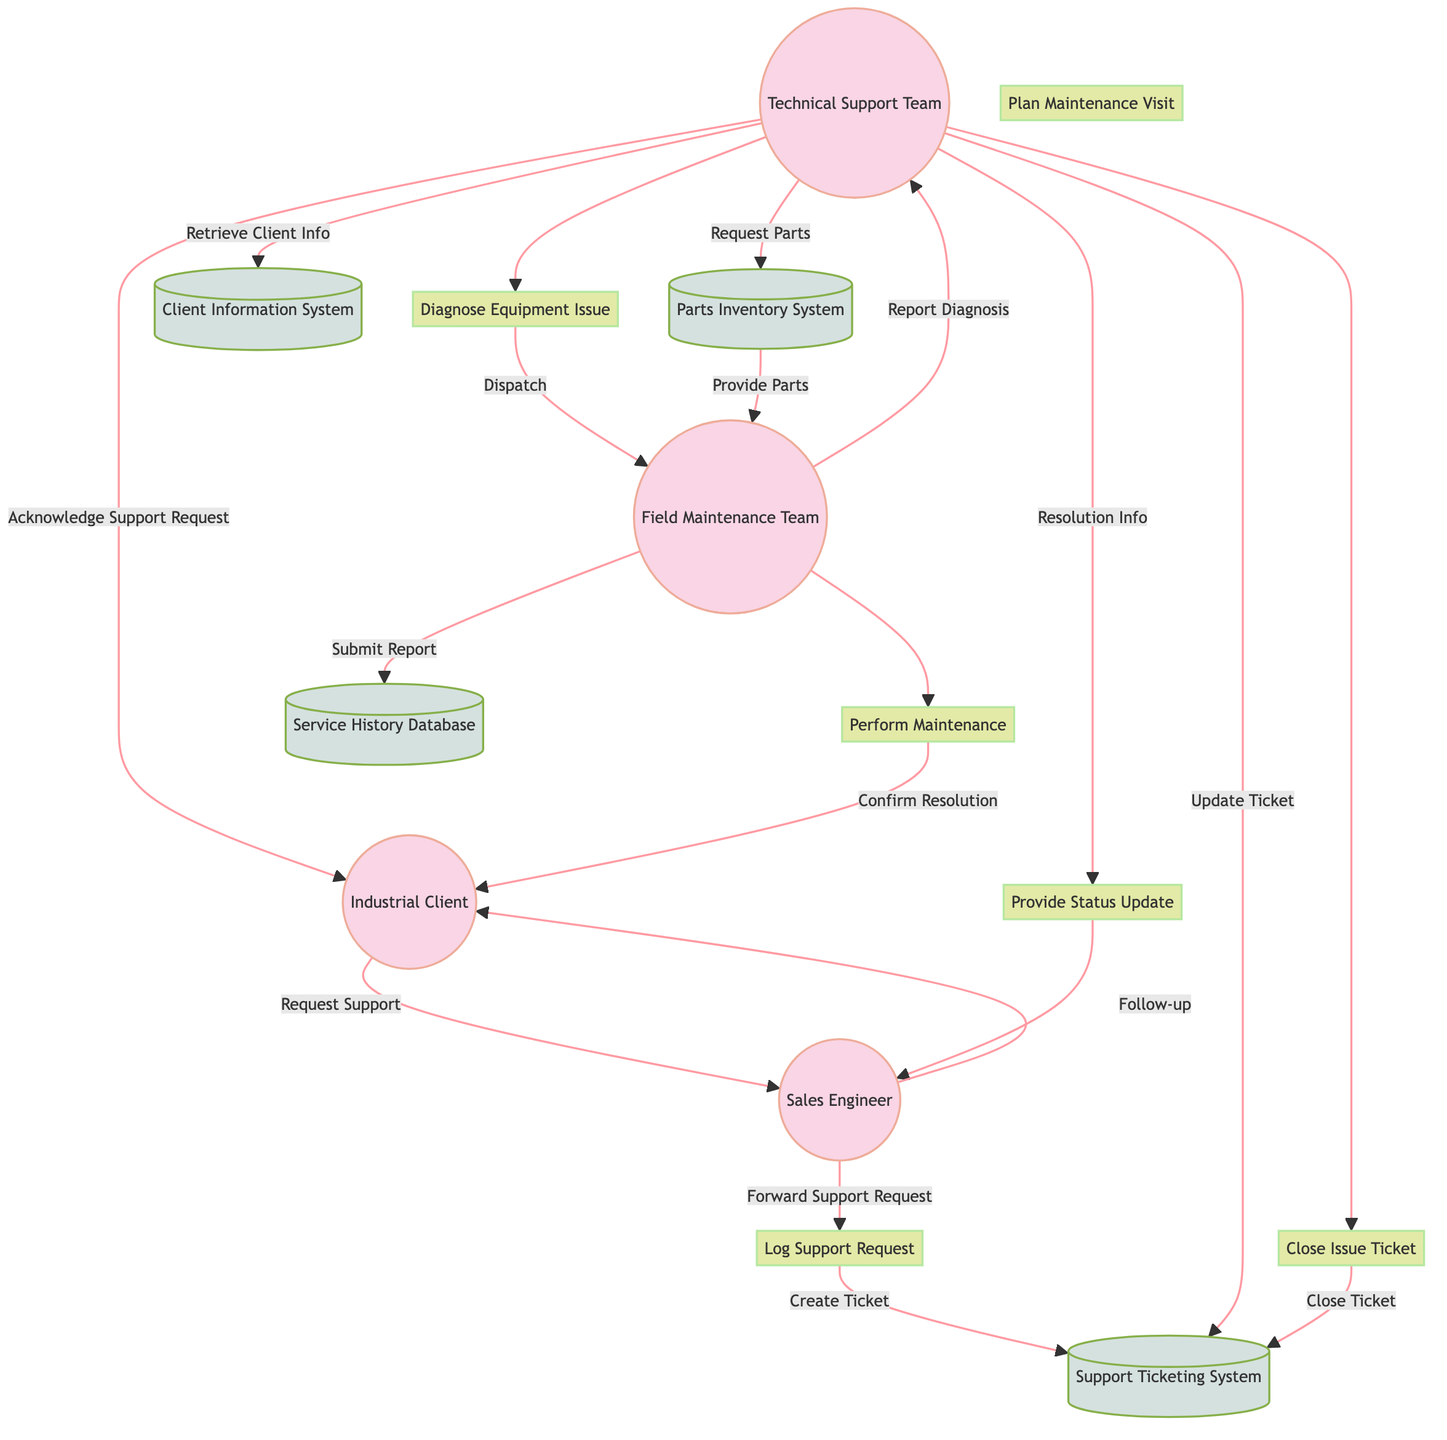What is the first step in the post-sales support workflow? The first step in the workflow is "Log Support Request," which is initiated when the Customer asks for support. This step is represented in the diagram as the process connected to the Customer entity through the "Request Support" data flow.
Answer: Log Support Request How many main processes are identified in the diagram? The diagram lists six main processes: Register Support Request, Analyze Issue, Schedule Maintenance, Fulfill Maintenance, Update Client, and Complete Ticket. This total is derived from counting the distinct process nodes in the diagram.
Answer: 6 Which entity acknowledges the support request to the customer? In the diagram, the Technical Support Team is responsible for acknowledging the support request. This is shown by the data flow that connects Tech Support to Customer with the label "Acknowledge Support Request."
Answer: Technical Support Team What happens after the Maintenance Crew reports the diagnosis? After the Maintenance Crew reports the diagnosis to Technical Support, the next action is for the Technical Support Team to request spare parts from the Inventory Database, as indicated by the connection in the diagram.
Answer: Request Spare Parts What is the final step for closing an issue ticket in the support workflow? The final step for closing an issue ticket is represented as "Close Issue Ticket," which indicates that once all processes are completed, this task is handled within the Ticketing System. This is reflected in the diagram where Complete Ticket leads to the Ticketing System with the flow "Close Ticket."
Answer: Close Issue Ticket Which process connects to the Maintenance Records datastore? The process that connects to the Maintenance Records datastore is "Submit Maintenance Report," which follows the maintenance activities performed by the Field Maintenance Team, as indicated by the flow in the diagram.
Answer: Submit Maintenance Report How does Technical Support update the salesperson? Technical Support updates the salesperson regarding the issue resolution through a process labeled "Update on Resolution," which links Tech Support to the Salesperson in the diagram.
Answer: Update on Resolution Which data store contains the client information? The Client Information System is the data store that contains the client information. This is clearly labeled as "CustomerDatabase" within the diagram.
Answer: Client Information System 